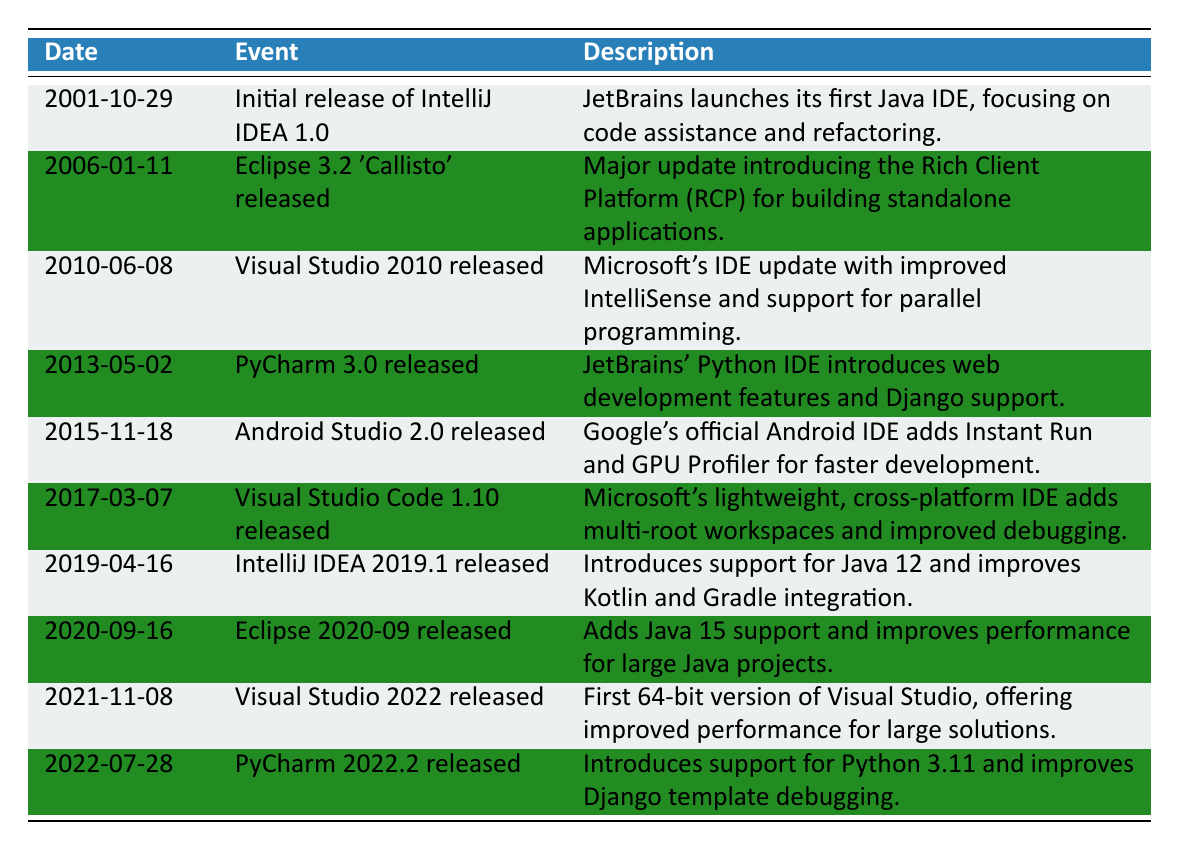What was the date of the initial release of IntelliJ IDEA 1.0? The date listed in the table for the initial release of IntelliJ IDEA 1.0 is 2001-10-29.
Answer: 2001-10-29 Which IDE was released on 2013-05-02? The table lists the IDE released on this date as PyCharm 3.0.
Answer: PyCharm 3.0 How many IDE updates were released before 2010? To answer, we count the events in the table before the year 2010. The relevant events are the initial release of IntelliJ IDEA and Eclipse 3.2, which amounts to 2 updates.
Answer: 2 Did Visual Studio 2022 improve performance for large solutions? According to the description in the table, Visual Studio 2022 was noted as offering improved performance for large solutions, which means this statement is true.
Answer: Yes Which IDE introduced support for Python 3.11? The table shows that PyCharm 2022.2 introduced support for Python 3.11.
Answer: PyCharm 2022.2 What event came immediately before the release of Android Studio 2.0? To find this, we look at the date order in the table. The event released immediately before Android Studio 2.0 (2015-11-18) is PyCharm 3.0 (2013-05-02).
Answer: PyCharm 3.0 How many years elapsed between the release of IntelliJ IDEA 1.0 and Visual Studio 2022? We calculate the years from 2001 to 2021. The difference is 2021 - 2001 = 20 years.
Answer: 20 Which IDE was the first to support Java 15? Referring to the table, Eclipse 2020-09, released on 2020-09-16, was the first to support Java 15.
Answer: Eclipse 2020-09 In which year were the most IDE releases listed in the table? By checking each year in the timeline, there is one release each in 2001, 2006, 2010, 2013, 2015, 2017, 2019, 2020, 2021, and 2022. Since each of these years only has one release, there is no year with multiple releases.
Answer: No year has multiple releases 